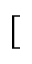<formula> <loc_0><loc_0><loc_500><loc_500>[</formula> 